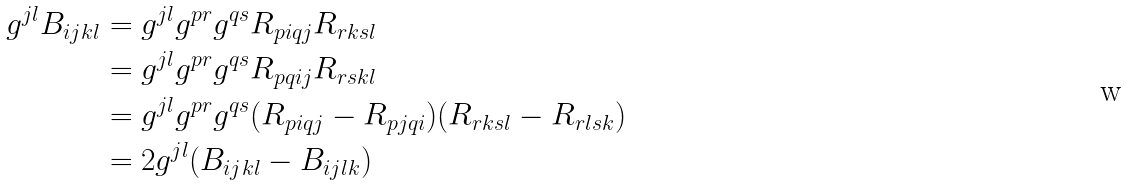<formula> <loc_0><loc_0><loc_500><loc_500>g ^ { j l } B _ { i j k l } & = g ^ { j l } g ^ { p r } g ^ { q s } R _ { p i q j } R _ { r k s l } \\ & = g ^ { j l } g ^ { p r } g ^ { q s } R _ { p q i j } R _ { r s k l } \\ & = g ^ { j l } g ^ { p r } g ^ { q s } ( R _ { p i q j } - R _ { p j q i } ) ( R _ { r k s l } - R _ { r l s k } ) \\ & = 2 g ^ { j l } ( B _ { i j k l } - B _ { i j l k } )</formula> 